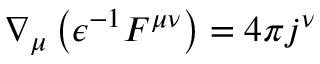Convert formula to latex. <formula><loc_0><loc_0><loc_500><loc_500>\nabla _ { \mu } \left ( \epsilon ^ { - 1 } F ^ { \mu \nu } \right ) = 4 \pi j ^ { \nu }</formula> 